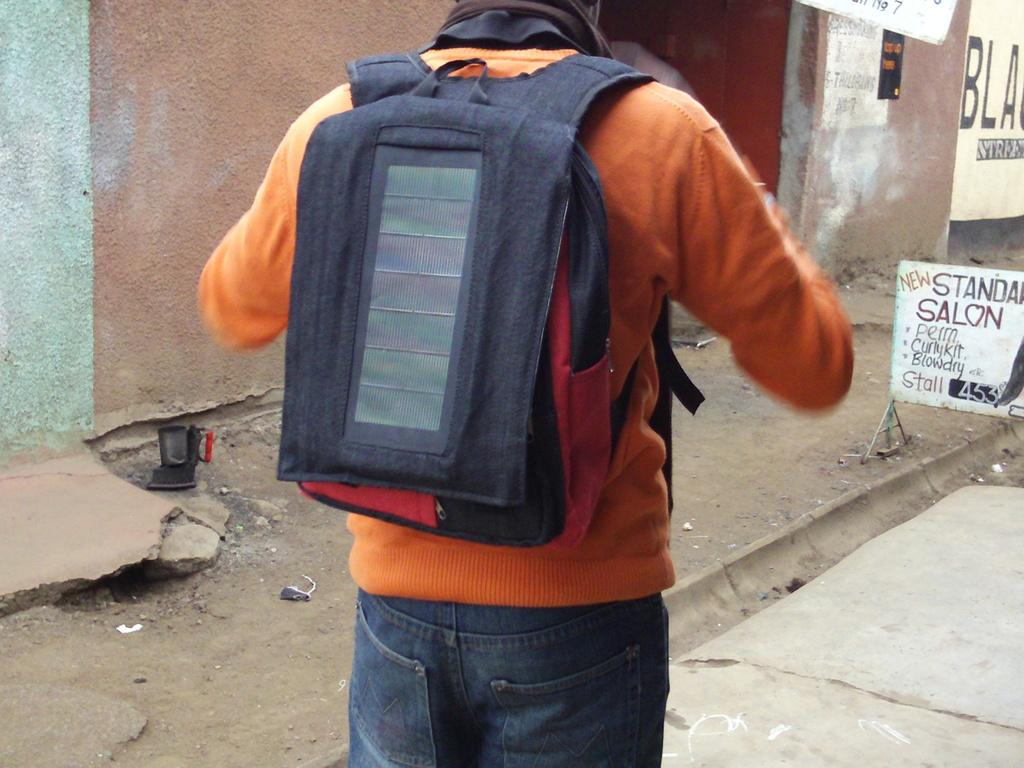Provide a one-sentence caption for the provided image. A man in an orange sweater has a backpack on by a Salon offering perms. 